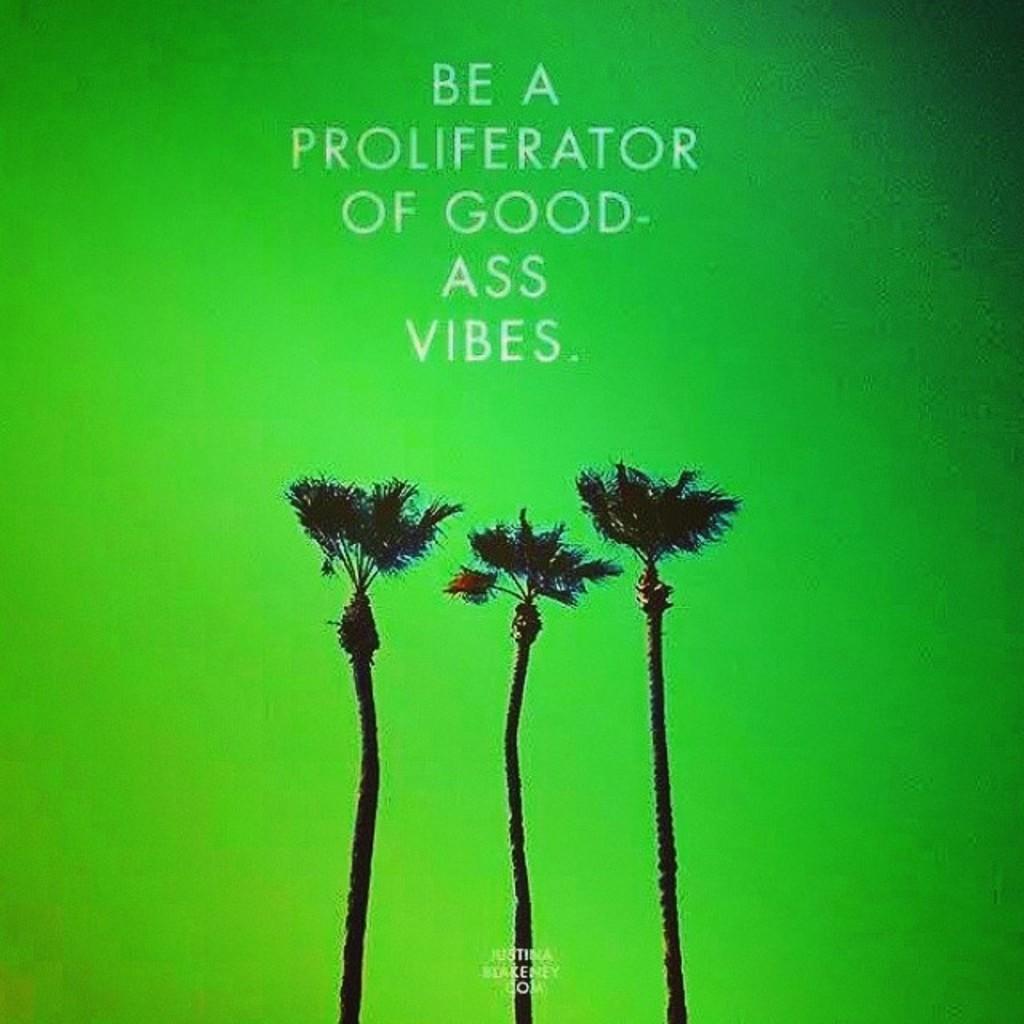How would you summarize this image in a sentence or two? In this image I can see few trees and here I can see something is written. I can also see green color in background. 